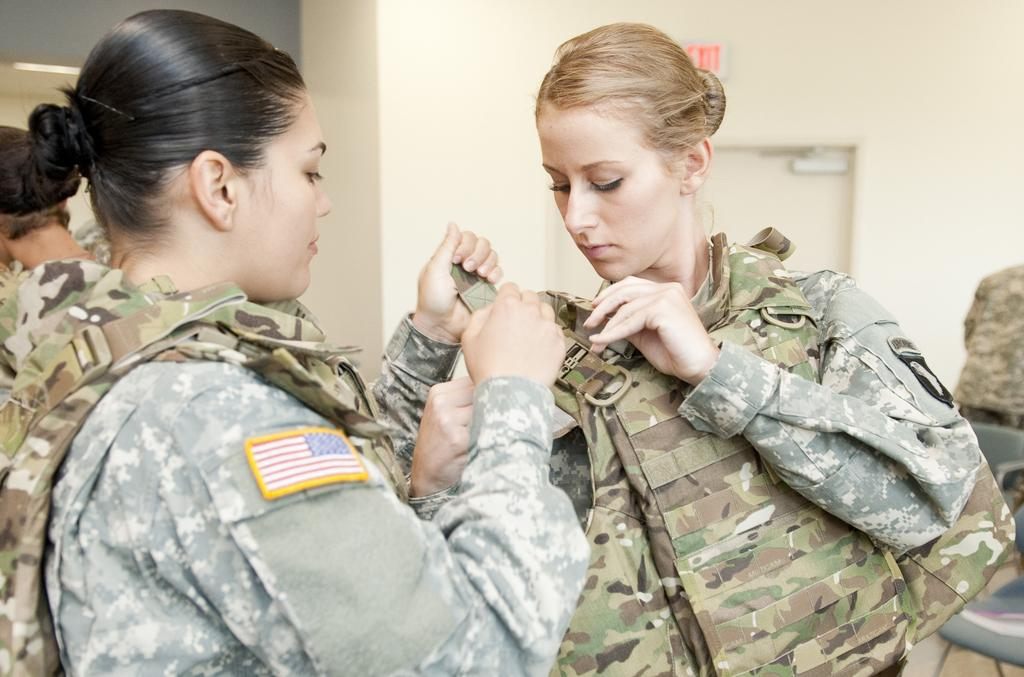How many people are in the image? There are two ladies in the image. What are the ladies wearing? The ladies are wearing uniforms. What can be seen in the background of the image? There is a wall in the background of the image. What features are present on the wall? There is a door and a sign board on the wall. What type of flag is being waved by the ladies in the image? There is no flag present in the image; the ladies are not waving anything. What time of day is it in the image, considering the morning light? The provided facts do not mention any information about the time of day or lighting conditions, so it cannot be determined from the image. 